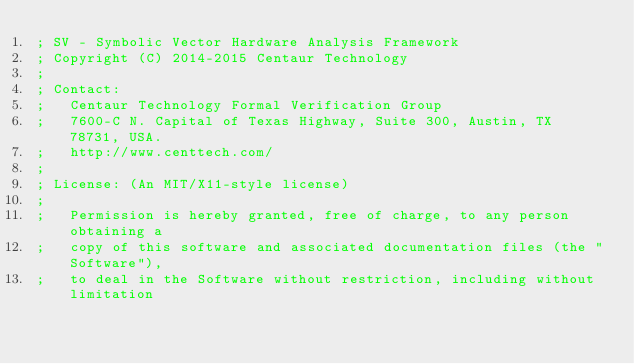<code> <loc_0><loc_0><loc_500><loc_500><_Lisp_>; SV - Symbolic Vector Hardware Analysis Framework
; Copyright (C) 2014-2015 Centaur Technology
;
; Contact:
;   Centaur Technology Formal Verification Group
;   7600-C N. Capital of Texas Highway, Suite 300, Austin, TX 78731, USA.
;   http://www.centtech.com/
;
; License: (An MIT/X11-style license)
;
;   Permission is hereby granted, free of charge, to any person obtaining a
;   copy of this software and associated documentation files (the "Software"),
;   to deal in the Software without restriction, including without limitation</code> 